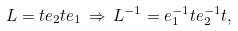Convert formula to latex. <formula><loc_0><loc_0><loc_500><loc_500>L = t e _ { 2 } t e _ { 1 } \, \Rightarrow \, L ^ { - 1 } = e _ { 1 } ^ { - 1 } t e _ { 2 } ^ { - 1 } t ,</formula> 